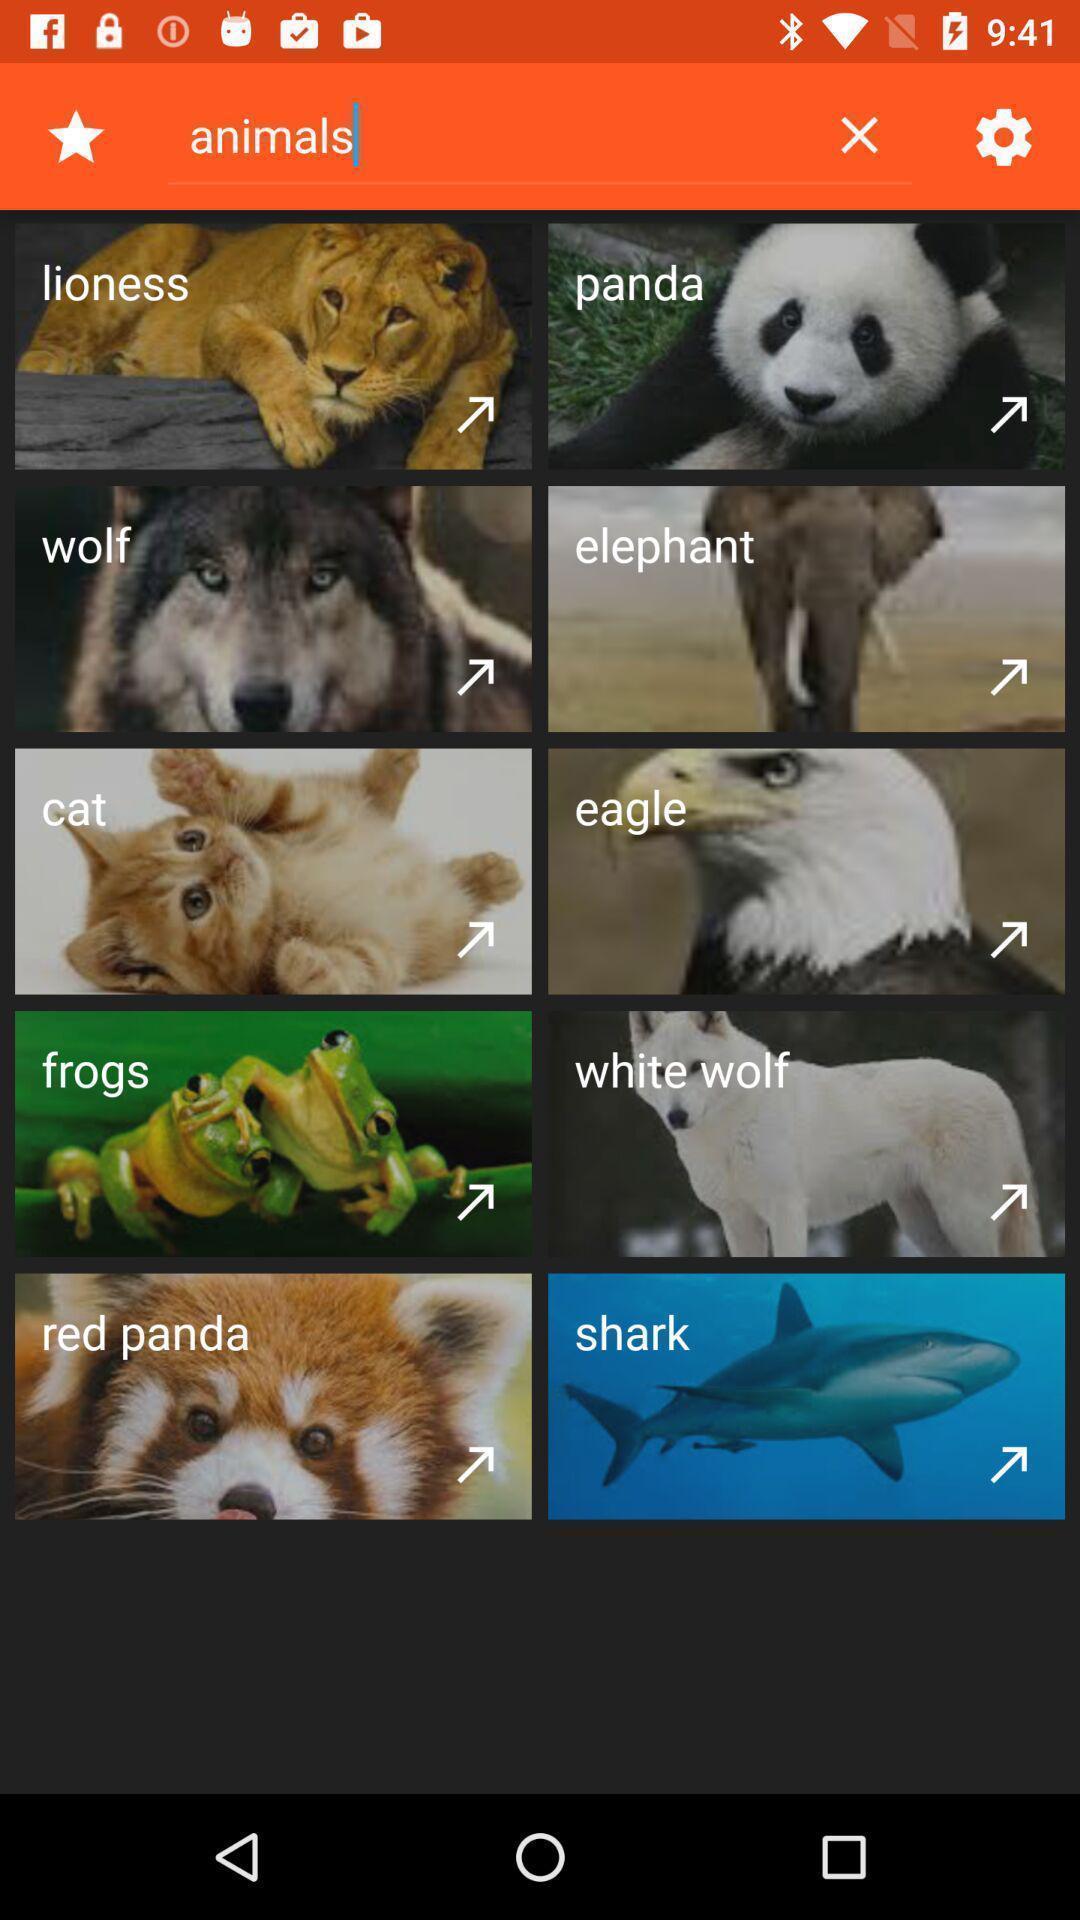Please provide a description for this image. Page showing list of animals. 